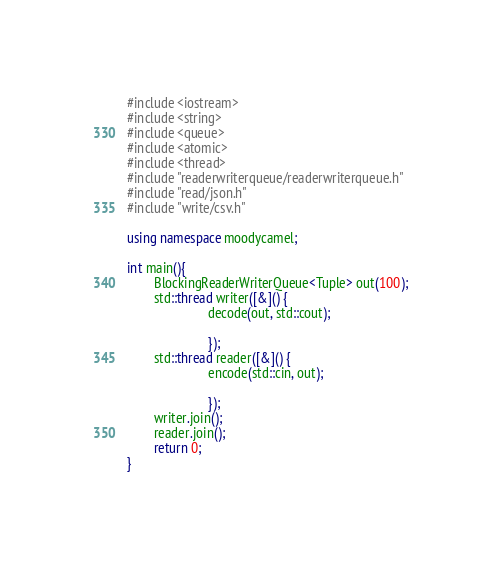Convert code to text. <code><loc_0><loc_0><loc_500><loc_500><_C++_>#include <iostream> 
#include <string>
#include <queue>
#include <atomic>
#include <thread>
#include "readerwriterqueue/readerwriterqueue.h"
#include "read/json.h"
#include "write/csv.h"

using namespace moodycamel;

int main(){
        BlockingReaderWriterQueue<Tuple> out(100);
        std::thread writer([&]() {
                        decode(out, std::cout);

                        });
        std::thread reader([&]() {
                        encode(std::cin, out);

                        });
        writer.join();
        reader.join();
        return 0;
}
</code> 